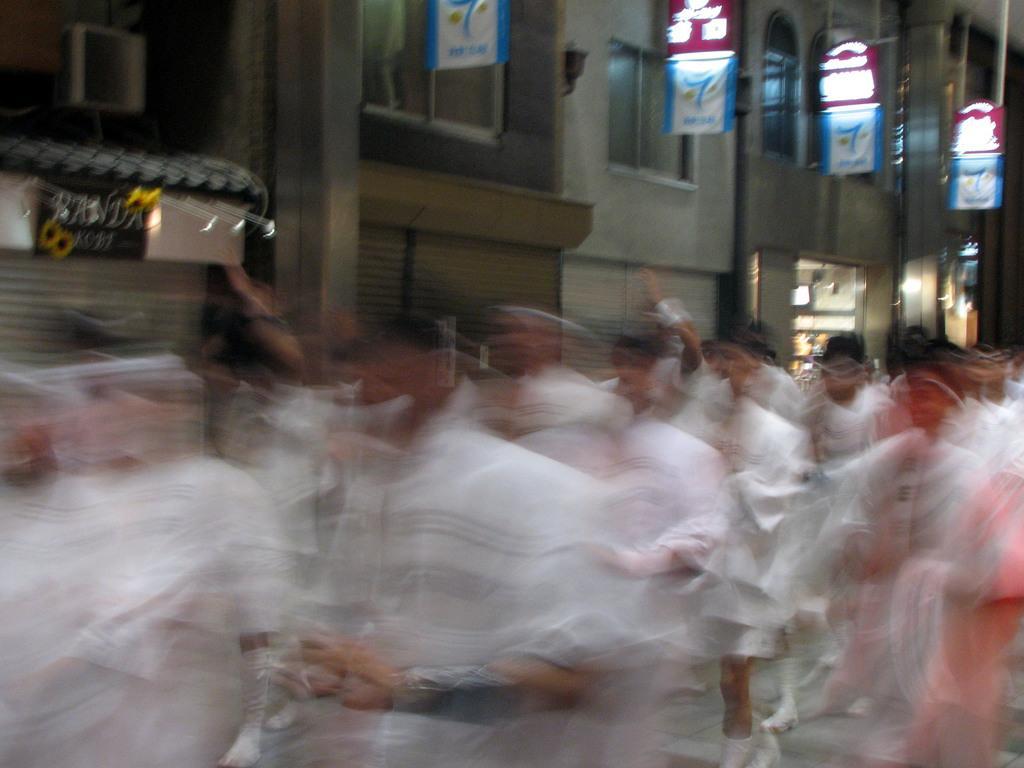Could you give a brief overview of what you see in this image? This picture look like few people walking and I can see a building and few boards with some text. 